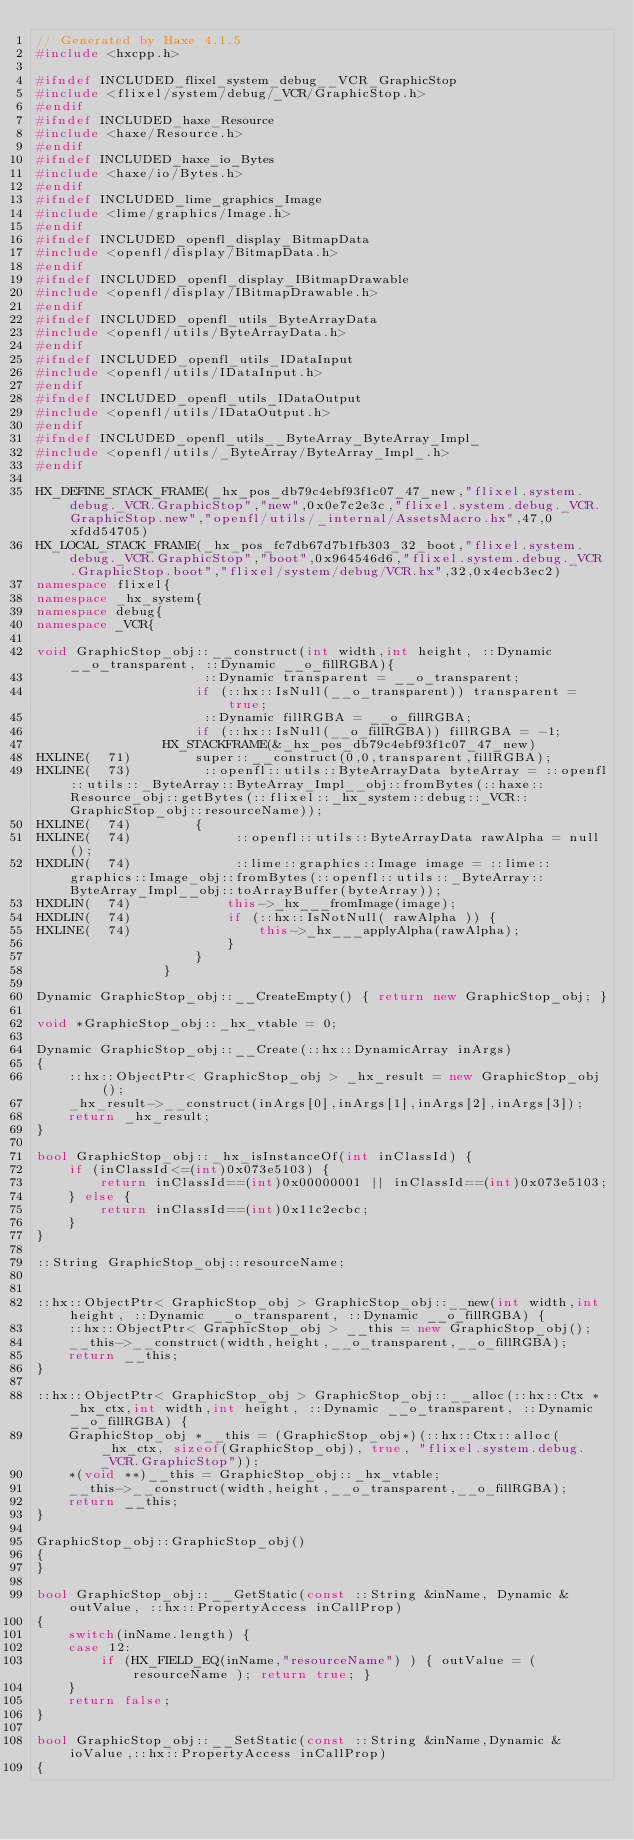<code> <loc_0><loc_0><loc_500><loc_500><_C++_>// Generated by Haxe 4.1.5
#include <hxcpp.h>

#ifndef INCLUDED_flixel_system_debug__VCR_GraphicStop
#include <flixel/system/debug/_VCR/GraphicStop.h>
#endif
#ifndef INCLUDED_haxe_Resource
#include <haxe/Resource.h>
#endif
#ifndef INCLUDED_haxe_io_Bytes
#include <haxe/io/Bytes.h>
#endif
#ifndef INCLUDED_lime_graphics_Image
#include <lime/graphics/Image.h>
#endif
#ifndef INCLUDED_openfl_display_BitmapData
#include <openfl/display/BitmapData.h>
#endif
#ifndef INCLUDED_openfl_display_IBitmapDrawable
#include <openfl/display/IBitmapDrawable.h>
#endif
#ifndef INCLUDED_openfl_utils_ByteArrayData
#include <openfl/utils/ByteArrayData.h>
#endif
#ifndef INCLUDED_openfl_utils_IDataInput
#include <openfl/utils/IDataInput.h>
#endif
#ifndef INCLUDED_openfl_utils_IDataOutput
#include <openfl/utils/IDataOutput.h>
#endif
#ifndef INCLUDED_openfl_utils__ByteArray_ByteArray_Impl_
#include <openfl/utils/_ByteArray/ByteArray_Impl_.h>
#endif

HX_DEFINE_STACK_FRAME(_hx_pos_db79c4ebf93f1c07_47_new,"flixel.system.debug._VCR.GraphicStop","new",0x0e7c2e3c,"flixel.system.debug._VCR.GraphicStop.new","openfl/utils/_internal/AssetsMacro.hx",47,0xfdd54705)
HX_LOCAL_STACK_FRAME(_hx_pos_fc7db67d7b1fb303_32_boot,"flixel.system.debug._VCR.GraphicStop","boot",0x964546d6,"flixel.system.debug._VCR.GraphicStop.boot","flixel/system/debug/VCR.hx",32,0x4ecb3ec2)
namespace flixel{
namespace _hx_system{
namespace debug{
namespace _VCR{

void GraphicStop_obj::__construct(int width,int height, ::Dynamic __o_transparent, ::Dynamic __o_fillRGBA){
            		 ::Dynamic transparent = __o_transparent;
            		if (::hx::IsNull(__o_transparent)) transparent = true;
            		 ::Dynamic fillRGBA = __o_fillRGBA;
            		if (::hx::IsNull(__o_fillRGBA)) fillRGBA = -1;
            	HX_STACKFRAME(&_hx_pos_db79c4ebf93f1c07_47_new)
HXLINE(  71)		super::__construct(0,0,transparent,fillRGBA);
HXLINE(  73)		 ::openfl::utils::ByteArrayData byteArray = ::openfl::utils::_ByteArray::ByteArray_Impl__obj::fromBytes(::haxe::Resource_obj::getBytes(::flixel::_hx_system::debug::_VCR::GraphicStop_obj::resourceName));
HXLINE(  74)		{
HXLINE(  74)			 ::openfl::utils::ByteArrayData rawAlpha = null();
HXDLIN(  74)			 ::lime::graphics::Image image = ::lime::graphics::Image_obj::fromBytes(::openfl::utils::_ByteArray::ByteArray_Impl__obj::toArrayBuffer(byteArray));
HXDLIN(  74)			this->_hx___fromImage(image);
HXDLIN(  74)			if (::hx::IsNotNull( rawAlpha )) {
HXLINE(  74)				this->_hx___applyAlpha(rawAlpha);
            			}
            		}
            	}

Dynamic GraphicStop_obj::__CreateEmpty() { return new GraphicStop_obj; }

void *GraphicStop_obj::_hx_vtable = 0;

Dynamic GraphicStop_obj::__Create(::hx::DynamicArray inArgs)
{
	::hx::ObjectPtr< GraphicStop_obj > _hx_result = new GraphicStop_obj();
	_hx_result->__construct(inArgs[0],inArgs[1],inArgs[2],inArgs[3]);
	return _hx_result;
}

bool GraphicStop_obj::_hx_isInstanceOf(int inClassId) {
	if (inClassId<=(int)0x073e5103) {
		return inClassId==(int)0x00000001 || inClassId==(int)0x073e5103;
	} else {
		return inClassId==(int)0x11c2ecbc;
	}
}

::String GraphicStop_obj::resourceName;


::hx::ObjectPtr< GraphicStop_obj > GraphicStop_obj::__new(int width,int height, ::Dynamic __o_transparent, ::Dynamic __o_fillRGBA) {
	::hx::ObjectPtr< GraphicStop_obj > __this = new GraphicStop_obj();
	__this->__construct(width,height,__o_transparent,__o_fillRGBA);
	return __this;
}

::hx::ObjectPtr< GraphicStop_obj > GraphicStop_obj::__alloc(::hx::Ctx *_hx_ctx,int width,int height, ::Dynamic __o_transparent, ::Dynamic __o_fillRGBA) {
	GraphicStop_obj *__this = (GraphicStop_obj*)(::hx::Ctx::alloc(_hx_ctx, sizeof(GraphicStop_obj), true, "flixel.system.debug._VCR.GraphicStop"));
	*(void **)__this = GraphicStop_obj::_hx_vtable;
	__this->__construct(width,height,__o_transparent,__o_fillRGBA);
	return __this;
}

GraphicStop_obj::GraphicStop_obj()
{
}

bool GraphicStop_obj::__GetStatic(const ::String &inName, Dynamic &outValue, ::hx::PropertyAccess inCallProp)
{
	switch(inName.length) {
	case 12:
		if (HX_FIELD_EQ(inName,"resourceName") ) { outValue = ( resourceName ); return true; }
	}
	return false;
}

bool GraphicStop_obj::__SetStatic(const ::String &inName,Dynamic &ioValue,::hx::PropertyAccess inCallProp)
{</code> 